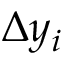Convert formula to latex. <formula><loc_0><loc_0><loc_500><loc_500>\Delta { y } _ { i }</formula> 